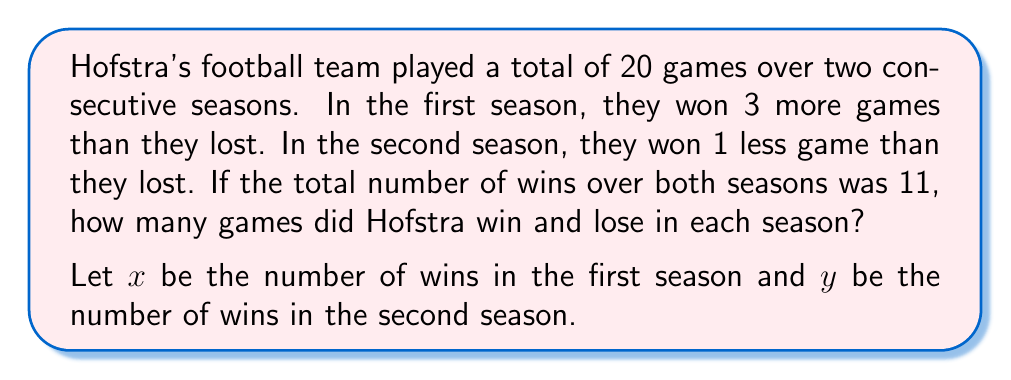Solve this math problem. Let's approach this problem step by step:

1) First, let's set up our system of equations based on the given information:

   Equation 1: $x + y = 11$ (total wins over both seasons)
   Equation 2: $x - (x-3) + y - (y+1) = 11$ (total games played)

2) Simplify Equation 2:
   $x - x + 3 + y - y - 1 = 11$
   $2 = 11$
   $20 = 20$ (this checks out with our given total of 20 games)

3) Now, let's use the information about each season:
   First season: $x - (x-3) = 10$ (total games in first season)
   Second season: $y - (y+1) = 10$ (total games in second season)

4) Solve for $x$ in the first season equation:
   $x - x + 3 = 10$
   $3 = 10$
   $x = 7$ (wins in first season)

5) Solve for $y$ in the second season equation:
   $y - y - 1 = 10$
   $-1 = 10$
   $y = 4$ (wins in second season)

6) Check our solution:
   Total wins: $7 + 4 = 11$ (matches given information)
   First season: 7 wins, 3 losses (7 - 3 = 4, which is 3 more wins than losses)
   Second season: 4 wins, 6 losses (4 - 6 = -2, which is 1 less win than losses)
   Total games: $7 + 3 + 4 + 6 = 20$ (matches given information)
Answer: Hofstra won 7 games and lost 3 games in the first season, and won 4 games and lost 6 games in the second season. 